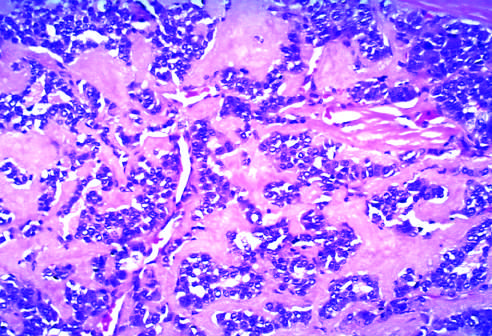s amyloid derived from calcitonin molecules secreted by the neoplastic cells?
Answer the question using a single word or phrase. Yes 